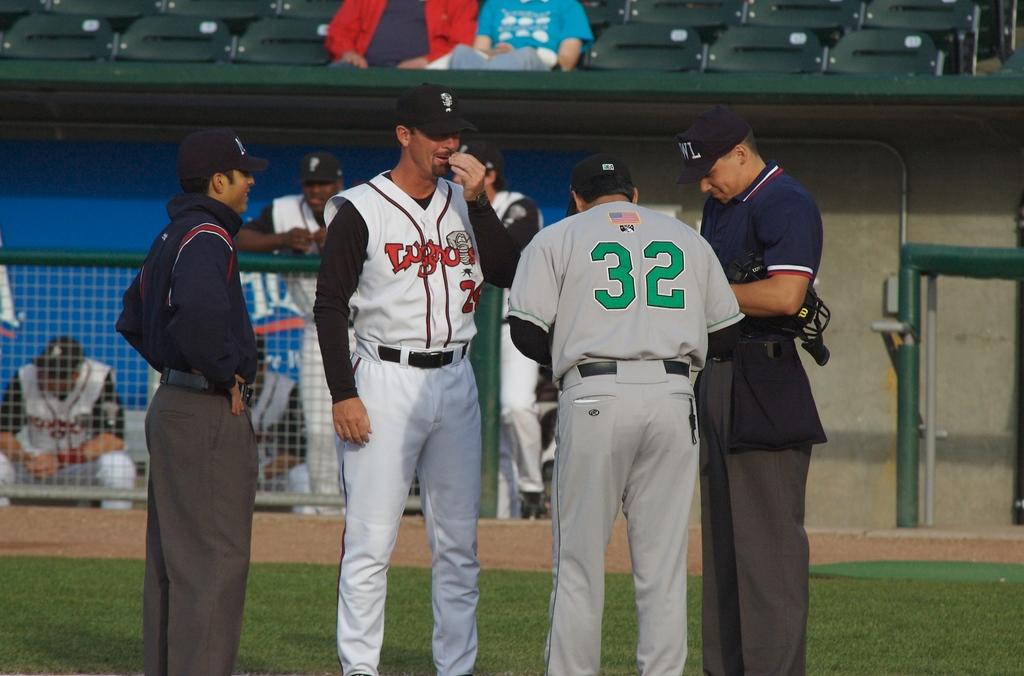What is the team listed on the white jersey?
Your response must be concise. Lugo. 